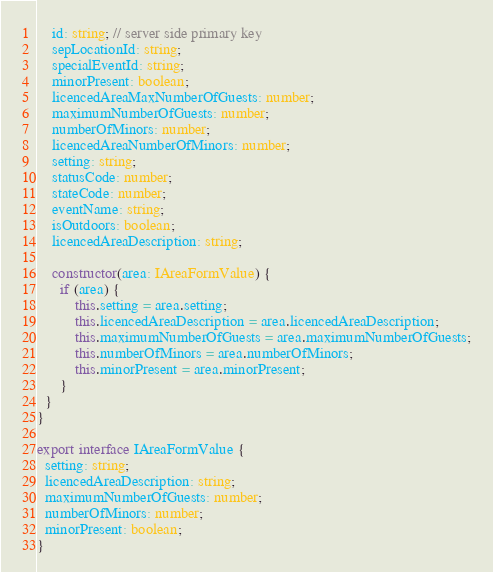Convert code to text. <code><loc_0><loc_0><loc_500><loc_500><_TypeScript_>    id: string; // server side primary key
    sepLocationId: string;
    specialEventId: string;
    minorPresent: boolean;
    licencedAreaMaxNumberOfGuests: number;
    maximumNumberOfGuests: number;
    numberOfMinors: number;
    licencedAreaNumberOfMinors: number;
    setting: string;
    statusCode: number;
    stateCode: number;
    eventName: string;
    isOutdoors: boolean;
    licencedAreaDescription: string;

    constructor(area: IAreaFormValue) {
      if (area) {
          this.setting = area.setting;
          this.licencedAreaDescription = area.licencedAreaDescription;
          this.maximumNumberOfGuests = area.maximumNumberOfGuests;
          this.numberOfMinors = area.numberOfMinors;
          this.minorPresent = area.minorPresent;
      }
  }
}

export interface IAreaFormValue {
  setting: string;
  licencedAreaDescription: string;
  maximumNumberOfGuests: number;
  numberOfMinors: number;
  minorPresent: boolean;
}
</code> 